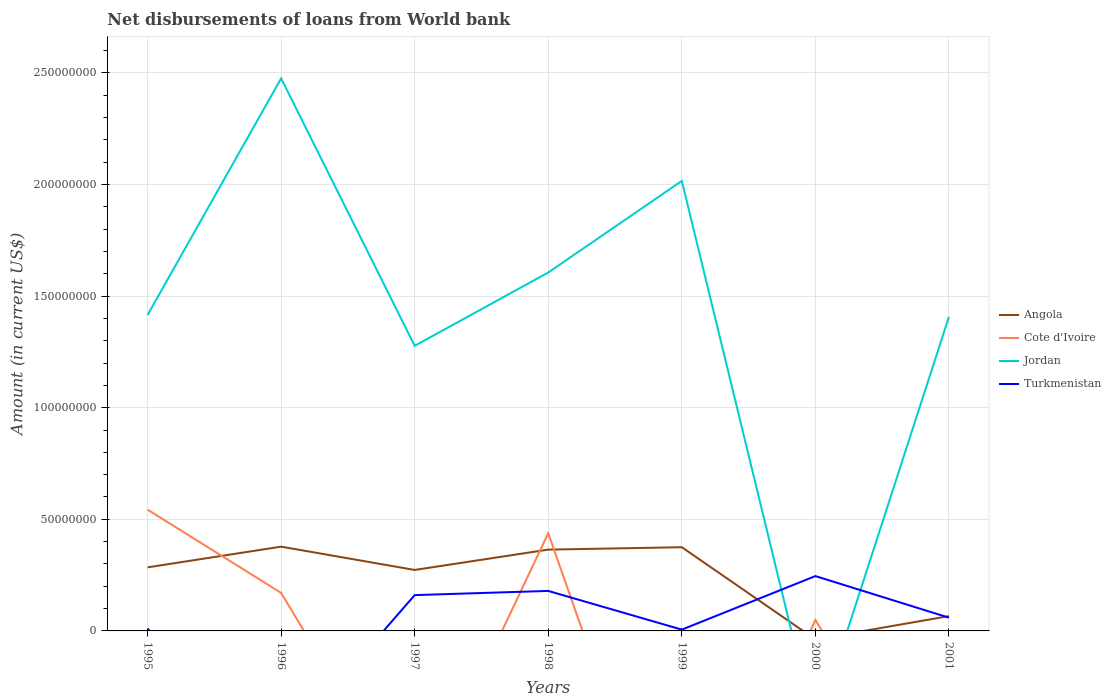Is the number of lines equal to the number of legend labels?
Your response must be concise. No. Across all years, what is the maximum amount of loan disbursed from World Bank in Jordan?
Offer a very short reply. 0. What is the total amount of loan disbursed from World Bank in Turkmenistan in the graph?
Provide a short and direct response. 1.86e+07. What is the difference between the highest and the second highest amount of loan disbursed from World Bank in Jordan?
Offer a very short reply. 2.48e+08. What is the difference between the highest and the lowest amount of loan disbursed from World Bank in Cote d'Ivoire?
Provide a short and direct response. 2. How many lines are there?
Provide a succinct answer. 4. How many years are there in the graph?
Your answer should be compact. 7. Are the values on the major ticks of Y-axis written in scientific E-notation?
Your answer should be very brief. No. Does the graph contain any zero values?
Offer a very short reply. Yes. Does the graph contain grids?
Make the answer very short. Yes. Where does the legend appear in the graph?
Your response must be concise. Center right. How many legend labels are there?
Offer a terse response. 4. How are the legend labels stacked?
Give a very brief answer. Vertical. What is the title of the graph?
Provide a succinct answer. Net disbursements of loans from World bank. What is the label or title of the Y-axis?
Offer a very short reply. Amount (in current US$). What is the Amount (in current US$) in Angola in 1995?
Make the answer very short. 2.85e+07. What is the Amount (in current US$) in Cote d'Ivoire in 1995?
Make the answer very short. 5.43e+07. What is the Amount (in current US$) of Jordan in 1995?
Make the answer very short. 1.42e+08. What is the Amount (in current US$) in Turkmenistan in 1995?
Ensure brevity in your answer.  9.57e+05. What is the Amount (in current US$) in Angola in 1996?
Ensure brevity in your answer.  3.78e+07. What is the Amount (in current US$) of Cote d'Ivoire in 1996?
Provide a succinct answer. 1.70e+07. What is the Amount (in current US$) in Jordan in 1996?
Offer a very short reply. 2.48e+08. What is the Amount (in current US$) of Turkmenistan in 1996?
Provide a succinct answer. 0. What is the Amount (in current US$) in Angola in 1997?
Your response must be concise. 2.73e+07. What is the Amount (in current US$) in Cote d'Ivoire in 1997?
Give a very brief answer. 0. What is the Amount (in current US$) of Jordan in 1997?
Keep it short and to the point. 1.28e+08. What is the Amount (in current US$) of Turkmenistan in 1997?
Give a very brief answer. 1.60e+07. What is the Amount (in current US$) of Angola in 1998?
Offer a terse response. 3.64e+07. What is the Amount (in current US$) in Cote d'Ivoire in 1998?
Give a very brief answer. 4.38e+07. What is the Amount (in current US$) in Jordan in 1998?
Offer a very short reply. 1.61e+08. What is the Amount (in current US$) in Turkmenistan in 1998?
Your answer should be compact. 1.79e+07. What is the Amount (in current US$) in Angola in 1999?
Your answer should be compact. 3.75e+07. What is the Amount (in current US$) of Jordan in 1999?
Offer a terse response. 2.02e+08. What is the Amount (in current US$) in Turkmenistan in 1999?
Offer a terse response. 5.75e+05. What is the Amount (in current US$) of Cote d'Ivoire in 2000?
Your answer should be compact. 4.92e+06. What is the Amount (in current US$) of Jordan in 2000?
Offer a very short reply. 0. What is the Amount (in current US$) of Turkmenistan in 2000?
Offer a very short reply. 2.46e+07. What is the Amount (in current US$) in Angola in 2001?
Keep it short and to the point. 6.63e+06. What is the Amount (in current US$) in Jordan in 2001?
Your answer should be compact. 1.41e+08. What is the Amount (in current US$) in Turkmenistan in 2001?
Give a very brief answer. 5.93e+06. Across all years, what is the maximum Amount (in current US$) in Angola?
Your answer should be very brief. 3.78e+07. Across all years, what is the maximum Amount (in current US$) in Cote d'Ivoire?
Your answer should be very brief. 5.43e+07. Across all years, what is the maximum Amount (in current US$) of Jordan?
Your answer should be very brief. 2.48e+08. Across all years, what is the maximum Amount (in current US$) of Turkmenistan?
Give a very brief answer. 2.46e+07. Across all years, what is the minimum Amount (in current US$) in Jordan?
Ensure brevity in your answer.  0. What is the total Amount (in current US$) of Angola in the graph?
Your response must be concise. 1.74e+08. What is the total Amount (in current US$) of Cote d'Ivoire in the graph?
Provide a short and direct response. 1.20e+08. What is the total Amount (in current US$) of Jordan in the graph?
Keep it short and to the point. 1.02e+09. What is the total Amount (in current US$) in Turkmenistan in the graph?
Give a very brief answer. 6.60e+07. What is the difference between the Amount (in current US$) in Angola in 1995 and that in 1996?
Your answer should be compact. -9.28e+06. What is the difference between the Amount (in current US$) of Cote d'Ivoire in 1995 and that in 1996?
Provide a short and direct response. 3.73e+07. What is the difference between the Amount (in current US$) of Jordan in 1995 and that in 1996?
Make the answer very short. -1.06e+08. What is the difference between the Amount (in current US$) of Angola in 1995 and that in 1997?
Your answer should be compact. 1.16e+06. What is the difference between the Amount (in current US$) of Jordan in 1995 and that in 1997?
Your response must be concise. 1.38e+07. What is the difference between the Amount (in current US$) in Turkmenistan in 1995 and that in 1997?
Make the answer very short. -1.51e+07. What is the difference between the Amount (in current US$) of Angola in 1995 and that in 1998?
Offer a very short reply. -7.95e+06. What is the difference between the Amount (in current US$) of Cote d'Ivoire in 1995 and that in 1998?
Offer a terse response. 1.06e+07. What is the difference between the Amount (in current US$) in Jordan in 1995 and that in 1998?
Your response must be concise. -1.90e+07. What is the difference between the Amount (in current US$) of Turkmenistan in 1995 and that in 1998?
Provide a short and direct response. -1.70e+07. What is the difference between the Amount (in current US$) of Angola in 1995 and that in 1999?
Keep it short and to the point. -9.03e+06. What is the difference between the Amount (in current US$) of Jordan in 1995 and that in 1999?
Your answer should be compact. -6.01e+07. What is the difference between the Amount (in current US$) of Turkmenistan in 1995 and that in 1999?
Your answer should be compact. 3.82e+05. What is the difference between the Amount (in current US$) in Cote d'Ivoire in 1995 and that in 2000?
Your response must be concise. 4.94e+07. What is the difference between the Amount (in current US$) in Turkmenistan in 1995 and that in 2000?
Give a very brief answer. -2.36e+07. What is the difference between the Amount (in current US$) in Angola in 1995 and that in 2001?
Give a very brief answer. 2.18e+07. What is the difference between the Amount (in current US$) in Jordan in 1995 and that in 2001?
Keep it short and to the point. 7.99e+05. What is the difference between the Amount (in current US$) in Turkmenistan in 1995 and that in 2001?
Offer a very short reply. -4.98e+06. What is the difference between the Amount (in current US$) of Angola in 1996 and that in 1997?
Keep it short and to the point. 1.04e+07. What is the difference between the Amount (in current US$) in Jordan in 1996 and that in 1997?
Provide a succinct answer. 1.20e+08. What is the difference between the Amount (in current US$) of Angola in 1996 and that in 1998?
Your answer should be very brief. 1.33e+06. What is the difference between the Amount (in current US$) of Cote d'Ivoire in 1996 and that in 1998?
Keep it short and to the point. -2.68e+07. What is the difference between the Amount (in current US$) of Jordan in 1996 and that in 1998?
Your response must be concise. 8.70e+07. What is the difference between the Amount (in current US$) in Angola in 1996 and that in 1999?
Provide a short and direct response. 2.51e+05. What is the difference between the Amount (in current US$) of Jordan in 1996 and that in 1999?
Offer a terse response. 4.59e+07. What is the difference between the Amount (in current US$) of Cote d'Ivoire in 1996 and that in 2000?
Your answer should be very brief. 1.21e+07. What is the difference between the Amount (in current US$) of Angola in 1996 and that in 2001?
Keep it short and to the point. 3.11e+07. What is the difference between the Amount (in current US$) of Jordan in 1996 and that in 2001?
Give a very brief answer. 1.07e+08. What is the difference between the Amount (in current US$) in Angola in 1997 and that in 1998?
Give a very brief answer. -9.11e+06. What is the difference between the Amount (in current US$) of Jordan in 1997 and that in 1998?
Your answer should be very brief. -3.28e+07. What is the difference between the Amount (in current US$) in Turkmenistan in 1997 and that in 1998?
Ensure brevity in your answer.  -1.87e+06. What is the difference between the Amount (in current US$) of Angola in 1997 and that in 1999?
Provide a succinct answer. -1.02e+07. What is the difference between the Amount (in current US$) of Jordan in 1997 and that in 1999?
Your response must be concise. -7.39e+07. What is the difference between the Amount (in current US$) in Turkmenistan in 1997 and that in 1999?
Your answer should be compact. 1.55e+07. What is the difference between the Amount (in current US$) of Turkmenistan in 1997 and that in 2000?
Provide a succinct answer. -8.52e+06. What is the difference between the Amount (in current US$) of Angola in 1997 and that in 2001?
Offer a terse response. 2.07e+07. What is the difference between the Amount (in current US$) of Jordan in 1997 and that in 2001?
Your answer should be very brief. -1.30e+07. What is the difference between the Amount (in current US$) in Turkmenistan in 1997 and that in 2001?
Ensure brevity in your answer.  1.01e+07. What is the difference between the Amount (in current US$) of Angola in 1998 and that in 1999?
Make the answer very short. -1.08e+06. What is the difference between the Amount (in current US$) of Jordan in 1998 and that in 1999?
Ensure brevity in your answer.  -4.10e+07. What is the difference between the Amount (in current US$) in Turkmenistan in 1998 and that in 1999?
Provide a short and direct response. 1.73e+07. What is the difference between the Amount (in current US$) in Cote d'Ivoire in 1998 and that in 2000?
Offer a terse response. 3.89e+07. What is the difference between the Amount (in current US$) in Turkmenistan in 1998 and that in 2000?
Make the answer very short. -6.65e+06. What is the difference between the Amount (in current US$) of Angola in 1998 and that in 2001?
Ensure brevity in your answer.  2.98e+07. What is the difference between the Amount (in current US$) in Jordan in 1998 and that in 2001?
Provide a succinct answer. 1.98e+07. What is the difference between the Amount (in current US$) of Turkmenistan in 1998 and that in 2001?
Your answer should be very brief. 1.20e+07. What is the difference between the Amount (in current US$) in Turkmenistan in 1999 and that in 2000?
Offer a terse response. -2.40e+07. What is the difference between the Amount (in current US$) in Angola in 1999 and that in 2001?
Provide a short and direct response. 3.09e+07. What is the difference between the Amount (in current US$) of Jordan in 1999 and that in 2001?
Your answer should be compact. 6.09e+07. What is the difference between the Amount (in current US$) of Turkmenistan in 1999 and that in 2001?
Offer a very short reply. -5.36e+06. What is the difference between the Amount (in current US$) in Turkmenistan in 2000 and that in 2001?
Offer a very short reply. 1.86e+07. What is the difference between the Amount (in current US$) in Angola in 1995 and the Amount (in current US$) in Cote d'Ivoire in 1996?
Make the answer very short. 1.14e+07. What is the difference between the Amount (in current US$) of Angola in 1995 and the Amount (in current US$) of Jordan in 1996?
Offer a very short reply. -2.19e+08. What is the difference between the Amount (in current US$) in Cote d'Ivoire in 1995 and the Amount (in current US$) in Jordan in 1996?
Ensure brevity in your answer.  -1.93e+08. What is the difference between the Amount (in current US$) of Angola in 1995 and the Amount (in current US$) of Jordan in 1997?
Offer a terse response. -9.93e+07. What is the difference between the Amount (in current US$) of Angola in 1995 and the Amount (in current US$) of Turkmenistan in 1997?
Offer a very short reply. 1.24e+07. What is the difference between the Amount (in current US$) of Cote d'Ivoire in 1995 and the Amount (in current US$) of Jordan in 1997?
Make the answer very short. -7.34e+07. What is the difference between the Amount (in current US$) of Cote d'Ivoire in 1995 and the Amount (in current US$) of Turkmenistan in 1997?
Make the answer very short. 3.83e+07. What is the difference between the Amount (in current US$) in Jordan in 1995 and the Amount (in current US$) in Turkmenistan in 1997?
Your response must be concise. 1.25e+08. What is the difference between the Amount (in current US$) in Angola in 1995 and the Amount (in current US$) in Cote d'Ivoire in 1998?
Your response must be concise. -1.53e+07. What is the difference between the Amount (in current US$) in Angola in 1995 and the Amount (in current US$) in Jordan in 1998?
Provide a short and direct response. -1.32e+08. What is the difference between the Amount (in current US$) of Angola in 1995 and the Amount (in current US$) of Turkmenistan in 1998?
Make the answer very short. 1.06e+07. What is the difference between the Amount (in current US$) in Cote d'Ivoire in 1995 and the Amount (in current US$) in Jordan in 1998?
Make the answer very short. -1.06e+08. What is the difference between the Amount (in current US$) of Cote d'Ivoire in 1995 and the Amount (in current US$) of Turkmenistan in 1998?
Your answer should be compact. 3.64e+07. What is the difference between the Amount (in current US$) in Jordan in 1995 and the Amount (in current US$) in Turkmenistan in 1998?
Offer a very short reply. 1.24e+08. What is the difference between the Amount (in current US$) in Angola in 1995 and the Amount (in current US$) in Jordan in 1999?
Make the answer very short. -1.73e+08. What is the difference between the Amount (in current US$) of Angola in 1995 and the Amount (in current US$) of Turkmenistan in 1999?
Keep it short and to the point. 2.79e+07. What is the difference between the Amount (in current US$) in Cote d'Ivoire in 1995 and the Amount (in current US$) in Jordan in 1999?
Your response must be concise. -1.47e+08. What is the difference between the Amount (in current US$) of Cote d'Ivoire in 1995 and the Amount (in current US$) of Turkmenistan in 1999?
Offer a terse response. 5.38e+07. What is the difference between the Amount (in current US$) in Jordan in 1995 and the Amount (in current US$) in Turkmenistan in 1999?
Offer a terse response. 1.41e+08. What is the difference between the Amount (in current US$) in Angola in 1995 and the Amount (in current US$) in Cote d'Ivoire in 2000?
Provide a succinct answer. 2.36e+07. What is the difference between the Amount (in current US$) of Angola in 1995 and the Amount (in current US$) of Turkmenistan in 2000?
Make the answer very short. 3.90e+06. What is the difference between the Amount (in current US$) in Cote d'Ivoire in 1995 and the Amount (in current US$) in Turkmenistan in 2000?
Provide a short and direct response. 2.98e+07. What is the difference between the Amount (in current US$) in Jordan in 1995 and the Amount (in current US$) in Turkmenistan in 2000?
Your answer should be very brief. 1.17e+08. What is the difference between the Amount (in current US$) in Angola in 1995 and the Amount (in current US$) in Jordan in 2001?
Your answer should be compact. -1.12e+08. What is the difference between the Amount (in current US$) in Angola in 1995 and the Amount (in current US$) in Turkmenistan in 2001?
Give a very brief answer. 2.25e+07. What is the difference between the Amount (in current US$) of Cote d'Ivoire in 1995 and the Amount (in current US$) of Jordan in 2001?
Your response must be concise. -8.64e+07. What is the difference between the Amount (in current US$) of Cote d'Ivoire in 1995 and the Amount (in current US$) of Turkmenistan in 2001?
Keep it short and to the point. 4.84e+07. What is the difference between the Amount (in current US$) of Jordan in 1995 and the Amount (in current US$) of Turkmenistan in 2001?
Provide a short and direct response. 1.36e+08. What is the difference between the Amount (in current US$) of Angola in 1996 and the Amount (in current US$) of Jordan in 1997?
Provide a succinct answer. -9.00e+07. What is the difference between the Amount (in current US$) in Angola in 1996 and the Amount (in current US$) in Turkmenistan in 1997?
Provide a succinct answer. 2.17e+07. What is the difference between the Amount (in current US$) in Cote d'Ivoire in 1996 and the Amount (in current US$) in Jordan in 1997?
Your answer should be compact. -1.11e+08. What is the difference between the Amount (in current US$) in Cote d'Ivoire in 1996 and the Amount (in current US$) in Turkmenistan in 1997?
Provide a short and direct response. 9.91e+05. What is the difference between the Amount (in current US$) of Jordan in 1996 and the Amount (in current US$) of Turkmenistan in 1997?
Offer a very short reply. 2.32e+08. What is the difference between the Amount (in current US$) of Angola in 1996 and the Amount (in current US$) of Cote d'Ivoire in 1998?
Keep it short and to the point. -6.04e+06. What is the difference between the Amount (in current US$) of Angola in 1996 and the Amount (in current US$) of Jordan in 1998?
Your answer should be very brief. -1.23e+08. What is the difference between the Amount (in current US$) in Angola in 1996 and the Amount (in current US$) in Turkmenistan in 1998?
Give a very brief answer. 1.98e+07. What is the difference between the Amount (in current US$) in Cote d'Ivoire in 1996 and the Amount (in current US$) in Jordan in 1998?
Keep it short and to the point. -1.44e+08. What is the difference between the Amount (in current US$) of Cote d'Ivoire in 1996 and the Amount (in current US$) of Turkmenistan in 1998?
Provide a succinct answer. -8.82e+05. What is the difference between the Amount (in current US$) of Jordan in 1996 and the Amount (in current US$) of Turkmenistan in 1998?
Offer a very short reply. 2.30e+08. What is the difference between the Amount (in current US$) of Angola in 1996 and the Amount (in current US$) of Jordan in 1999?
Keep it short and to the point. -1.64e+08. What is the difference between the Amount (in current US$) in Angola in 1996 and the Amount (in current US$) in Turkmenistan in 1999?
Give a very brief answer. 3.72e+07. What is the difference between the Amount (in current US$) in Cote d'Ivoire in 1996 and the Amount (in current US$) in Jordan in 1999?
Offer a very short reply. -1.85e+08. What is the difference between the Amount (in current US$) in Cote d'Ivoire in 1996 and the Amount (in current US$) in Turkmenistan in 1999?
Give a very brief answer. 1.65e+07. What is the difference between the Amount (in current US$) in Jordan in 1996 and the Amount (in current US$) in Turkmenistan in 1999?
Provide a succinct answer. 2.47e+08. What is the difference between the Amount (in current US$) in Angola in 1996 and the Amount (in current US$) in Cote d'Ivoire in 2000?
Provide a succinct answer. 3.28e+07. What is the difference between the Amount (in current US$) in Angola in 1996 and the Amount (in current US$) in Turkmenistan in 2000?
Offer a very short reply. 1.32e+07. What is the difference between the Amount (in current US$) in Cote d'Ivoire in 1996 and the Amount (in current US$) in Turkmenistan in 2000?
Keep it short and to the point. -7.53e+06. What is the difference between the Amount (in current US$) of Jordan in 1996 and the Amount (in current US$) of Turkmenistan in 2000?
Your answer should be compact. 2.23e+08. What is the difference between the Amount (in current US$) in Angola in 1996 and the Amount (in current US$) in Jordan in 2001?
Give a very brief answer. -1.03e+08. What is the difference between the Amount (in current US$) in Angola in 1996 and the Amount (in current US$) in Turkmenistan in 2001?
Your answer should be very brief. 3.18e+07. What is the difference between the Amount (in current US$) of Cote d'Ivoire in 1996 and the Amount (in current US$) of Jordan in 2001?
Your response must be concise. -1.24e+08. What is the difference between the Amount (in current US$) in Cote d'Ivoire in 1996 and the Amount (in current US$) in Turkmenistan in 2001?
Your answer should be very brief. 1.11e+07. What is the difference between the Amount (in current US$) of Jordan in 1996 and the Amount (in current US$) of Turkmenistan in 2001?
Your answer should be compact. 2.42e+08. What is the difference between the Amount (in current US$) in Angola in 1997 and the Amount (in current US$) in Cote d'Ivoire in 1998?
Provide a succinct answer. -1.65e+07. What is the difference between the Amount (in current US$) of Angola in 1997 and the Amount (in current US$) of Jordan in 1998?
Provide a succinct answer. -1.33e+08. What is the difference between the Amount (in current US$) in Angola in 1997 and the Amount (in current US$) in Turkmenistan in 1998?
Provide a short and direct response. 9.40e+06. What is the difference between the Amount (in current US$) in Jordan in 1997 and the Amount (in current US$) in Turkmenistan in 1998?
Ensure brevity in your answer.  1.10e+08. What is the difference between the Amount (in current US$) of Angola in 1997 and the Amount (in current US$) of Jordan in 1999?
Make the answer very short. -1.74e+08. What is the difference between the Amount (in current US$) in Angola in 1997 and the Amount (in current US$) in Turkmenistan in 1999?
Your response must be concise. 2.67e+07. What is the difference between the Amount (in current US$) of Jordan in 1997 and the Amount (in current US$) of Turkmenistan in 1999?
Provide a succinct answer. 1.27e+08. What is the difference between the Amount (in current US$) in Angola in 1997 and the Amount (in current US$) in Cote d'Ivoire in 2000?
Your answer should be compact. 2.24e+07. What is the difference between the Amount (in current US$) in Angola in 1997 and the Amount (in current US$) in Turkmenistan in 2000?
Give a very brief answer. 2.75e+06. What is the difference between the Amount (in current US$) of Jordan in 1997 and the Amount (in current US$) of Turkmenistan in 2000?
Give a very brief answer. 1.03e+08. What is the difference between the Amount (in current US$) of Angola in 1997 and the Amount (in current US$) of Jordan in 2001?
Keep it short and to the point. -1.13e+08. What is the difference between the Amount (in current US$) in Angola in 1997 and the Amount (in current US$) in Turkmenistan in 2001?
Your answer should be compact. 2.14e+07. What is the difference between the Amount (in current US$) of Jordan in 1997 and the Amount (in current US$) of Turkmenistan in 2001?
Your answer should be very brief. 1.22e+08. What is the difference between the Amount (in current US$) in Angola in 1998 and the Amount (in current US$) in Jordan in 1999?
Your answer should be very brief. -1.65e+08. What is the difference between the Amount (in current US$) of Angola in 1998 and the Amount (in current US$) of Turkmenistan in 1999?
Make the answer very short. 3.58e+07. What is the difference between the Amount (in current US$) of Cote d'Ivoire in 1998 and the Amount (in current US$) of Jordan in 1999?
Offer a terse response. -1.58e+08. What is the difference between the Amount (in current US$) of Cote d'Ivoire in 1998 and the Amount (in current US$) of Turkmenistan in 1999?
Your answer should be compact. 4.32e+07. What is the difference between the Amount (in current US$) of Jordan in 1998 and the Amount (in current US$) of Turkmenistan in 1999?
Offer a very short reply. 1.60e+08. What is the difference between the Amount (in current US$) in Angola in 1998 and the Amount (in current US$) in Cote d'Ivoire in 2000?
Make the answer very short. 3.15e+07. What is the difference between the Amount (in current US$) of Angola in 1998 and the Amount (in current US$) of Turkmenistan in 2000?
Your answer should be very brief. 1.19e+07. What is the difference between the Amount (in current US$) of Cote d'Ivoire in 1998 and the Amount (in current US$) of Turkmenistan in 2000?
Ensure brevity in your answer.  1.92e+07. What is the difference between the Amount (in current US$) in Jordan in 1998 and the Amount (in current US$) in Turkmenistan in 2000?
Make the answer very short. 1.36e+08. What is the difference between the Amount (in current US$) of Angola in 1998 and the Amount (in current US$) of Jordan in 2001?
Offer a very short reply. -1.04e+08. What is the difference between the Amount (in current US$) of Angola in 1998 and the Amount (in current US$) of Turkmenistan in 2001?
Your answer should be very brief. 3.05e+07. What is the difference between the Amount (in current US$) of Cote d'Ivoire in 1998 and the Amount (in current US$) of Jordan in 2001?
Your response must be concise. -9.69e+07. What is the difference between the Amount (in current US$) in Cote d'Ivoire in 1998 and the Amount (in current US$) in Turkmenistan in 2001?
Your response must be concise. 3.79e+07. What is the difference between the Amount (in current US$) in Jordan in 1998 and the Amount (in current US$) in Turkmenistan in 2001?
Provide a short and direct response. 1.55e+08. What is the difference between the Amount (in current US$) in Angola in 1999 and the Amount (in current US$) in Cote d'Ivoire in 2000?
Keep it short and to the point. 3.26e+07. What is the difference between the Amount (in current US$) of Angola in 1999 and the Amount (in current US$) of Turkmenistan in 2000?
Offer a terse response. 1.29e+07. What is the difference between the Amount (in current US$) of Jordan in 1999 and the Amount (in current US$) of Turkmenistan in 2000?
Offer a terse response. 1.77e+08. What is the difference between the Amount (in current US$) in Angola in 1999 and the Amount (in current US$) in Jordan in 2001?
Ensure brevity in your answer.  -1.03e+08. What is the difference between the Amount (in current US$) of Angola in 1999 and the Amount (in current US$) of Turkmenistan in 2001?
Your response must be concise. 3.16e+07. What is the difference between the Amount (in current US$) in Jordan in 1999 and the Amount (in current US$) in Turkmenistan in 2001?
Offer a very short reply. 1.96e+08. What is the difference between the Amount (in current US$) of Cote d'Ivoire in 2000 and the Amount (in current US$) of Jordan in 2001?
Provide a short and direct response. -1.36e+08. What is the difference between the Amount (in current US$) in Cote d'Ivoire in 2000 and the Amount (in current US$) in Turkmenistan in 2001?
Provide a short and direct response. -1.01e+06. What is the average Amount (in current US$) of Angola per year?
Keep it short and to the point. 2.49e+07. What is the average Amount (in current US$) in Cote d'Ivoire per year?
Keep it short and to the point. 1.72e+07. What is the average Amount (in current US$) in Jordan per year?
Your response must be concise. 1.46e+08. What is the average Amount (in current US$) in Turkmenistan per year?
Provide a succinct answer. 9.43e+06. In the year 1995, what is the difference between the Amount (in current US$) of Angola and Amount (in current US$) of Cote d'Ivoire?
Make the answer very short. -2.59e+07. In the year 1995, what is the difference between the Amount (in current US$) of Angola and Amount (in current US$) of Jordan?
Your response must be concise. -1.13e+08. In the year 1995, what is the difference between the Amount (in current US$) of Angola and Amount (in current US$) of Turkmenistan?
Offer a very short reply. 2.75e+07. In the year 1995, what is the difference between the Amount (in current US$) of Cote d'Ivoire and Amount (in current US$) of Jordan?
Ensure brevity in your answer.  -8.72e+07. In the year 1995, what is the difference between the Amount (in current US$) in Cote d'Ivoire and Amount (in current US$) in Turkmenistan?
Your answer should be compact. 5.34e+07. In the year 1995, what is the difference between the Amount (in current US$) of Jordan and Amount (in current US$) of Turkmenistan?
Make the answer very short. 1.41e+08. In the year 1996, what is the difference between the Amount (in current US$) of Angola and Amount (in current US$) of Cote d'Ivoire?
Offer a very short reply. 2.07e+07. In the year 1996, what is the difference between the Amount (in current US$) in Angola and Amount (in current US$) in Jordan?
Your response must be concise. -2.10e+08. In the year 1996, what is the difference between the Amount (in current US$) in Cote d'Ivoire and Amount (in current US$) in Jordan?
Ensure brevity in your answer.  -2.31e+08. In the year 1997, what is the difference between the Amount (in current US$) of Angola and Amount (in current US$) of Jordan?
Your response must be concise. -1.00e+08. In the year 1997, what is the difference between the Amount (in current US$) in Angola and Amount (in current US$) in Turkmenistan?
Offer a terse response. 1.13e+07. In the year 1997, what is the difference between the Amount (in current US$) in Jordan and Amount (in current US$) in Turkmenistan?
Keep it short and to the point. 1.12e+08. In the year 1998, what is the difference between the Amount (in current US$) in Angola and Amount (in current US$) in Cote d'Ivoire?
Your response must be concise. -7.36e+06. In the year 1998, what is the difference between the Amount (in current US$) in Angola and Amount (in current US$) in Jordan?
Ensure brevity in your answer.  -1.24e+08. In the year 1998, what is the difference between the Amount (in current US$) of Angola and Amount (in current US$) of Turkmenistan?
Provide a short and direct response. 1.85e+07. In the year 1998, what is the difference between the Amount (in current US$) of Cote d'Ivoire and Amount (in current US$) of Jordan?
Your response must be concise. -1.17e+08. In the year 1998, what is the difference between the Amount (in current US$) in Cote d'Ivoire and Amount (in current US$) in Turkmenistan?
Provide a short and direct response. 2.59e+07. In the year 1998, what is the difference between the Amount (in current US$) in Jordan and Amount (in current US$) in Turkmenistan?
Offer a terse response. 1.43e+08. In the year 1999, what is the difference between the Amount (in current US$) in Angola and Amount (in current US$) in Jordan?
Your response must be concise. -1.64e+08. In the year 1999, what is the difference between the Amount (in current US$) in Angola and Amount (in current US$) in Turkmenistan?
Your answer should be very brief. 3.69e+07. In the year 1999, what is the difference between the Amount (in current US$) of Jordan and Amount (in current US$) of Turkmenistan?
Offer a very short reply. 2.01e+08. In the year 2000, what is the difference between the Amount (in current US$) in Cote d'Ivoire and Amount (in current US$) in Turkmenistan?
Your response must be concise. -1.96e+07. In the year 2001, what is the difference between the Amount (in current US$) in Angola and Amount (in current US$) in Jordan?
Provide a short and direct response. -1.34e+08. In the year 2001, what is the difference between the Amount (in current US$) in Angola and Amount (in current US$) in Turkmenistan?
Provide a short and direct response. 7.01e+05. In the year 2001, what is the difference between the Amount (in current US$) of Jordan and Amount (in current US$) of Turkmenistan?
Offer a very short reply. 1.35e+08. What is the ratio of the Amount (in current US$) in Angola in 1995 to that in 1996?
Your answer should be compact. 0.75. What is the ratio of the Amount (in current US$) in Cote d'Ivoire in 1995 to that in 1996?
Your answer should be very brief. 3.19. What is the ratio of the Amount (in current US$) of Jordan in 1995 to that in 1996?
Your answer should be very brief. 0.57. What is the ratio of the Amount (in current US$) in Angola in 1995 to that in 1997?
Make the answer very short. 1.04. What is the ratio of the Amount (in current US$) of Jordan in 1995 to that in 1997?
Ensure brevity in your answer.  1.11. What is the ratio of the Amount (in current US$) of Turkmenistan in 1995 to that in 1997?
Provide a short and direct response. 0.06. What is the ratio of the Amount (in current US$) of Angola in 1995 to that in 1998?
Ensure brevity in your answer.  0.78. What is the ratio of the Amount (in current US$) in Cote d'Ivoire in 1995 to that in 1998?
Ensure brevity in your answer.  1.24. What is the ratio of the Amount (in current US$) of Jordan in 1995 to that in 1998?
Your response must be concise. 0.88. What is the ratio of the Amount (in current US$) in Turkmenistan in 1995 to that in 1998?
Keep it short and to the point. 0.05. What is the ratio of the Amount (in current US$) in Angola in 1995 to that in 1999?
Your answer should be very brief. 0.76. What is the ratio of the Amount (in current US$) in Jordan in 1995 to that in 1999?
Offer a very short reply. 0.7. What is the ratio of the Amount (in current US$) in Turkmenistan in 1995 to that in 1999?
Your answer should be very brief. 1.66. What is the ratio of the Amount (in current US$) of Cote d'Ivoire in 1995 to that in 2000?
Your answer should be very brief. 11.05. What is the ratio of the Amount (in current US$) of Turkmenistan in 1995 to that in 2000?
Ensure brevity in your answer.  0.04. What is the ratio of the Amount (in current US$) of Angola in 1995 to that in 2001?
Make the answer very short. 4.29. What is the ratio of the Amount (in current US$) of Jordan in 1995 to that in 2001?
Make the answer very short. 1.01. What is the ratio of the Amount (in current US$) of Turkmenistan in 1995 to that in 2001?
Your answer should be very brief. 0.16. What is the ratio of the Amount (in current US$) of Angola in 1996 to that in 1997?
Your response must be concise. 1.38. What is the ratio of the Amount (in current US$) in Jordan in 1996 to that in 1997?
Keep it short and to the point. 1.94. What is the ratio of the Amount (in current US$) of Angola in 1996 to that in 1998?
Your answer should be very brief. 1.04. What is the ratio of the Amount (in current US$) in Cote d'Ivoire in 1996 to that in 1998?
Offer a very short reply. 0.39. What is the ratio of the Amount (in current US$) of Jordan in 1996 to that in 1998?
Provide a short and direct response. 1.54. What is the ratio of the Amount (in current US$) in Jordan in 1996 to that in 1999?
Your answer should be very brief. 1.23. What is the ratio of the Amount (in current US$) of Cote d'Ivoire in 1996 to that in 2000?
Make the answer very short. 3.46. What is the ratio of the Amount (in current US$) in Angola in 1996 to that in 2001?
Your answer should be very brief. 5.69. What is the ratio of the Amount (in current US$) in Jordan in 1996 to that in 2001?
Keep it short and to the point. 1.76. What is the ratio of the Amount (in current US$) in Angola in 1997 to that in 1998?
Your response must be concise. 0.75. What is the ratio of the Amount (in current US$) of Jordan in 1997 to that in 1998?
Offer a terse response. 0.8. What is the ratio of the Amount (in current US$) in Turkmenistan in 1997 to that in 1998?
Offer a very short reply. 0.9. What is the ratio of the Amount (in current US$) of Angola in 1997 to that in 1999?
Provide a short and direct response. 0.73. What is the ratio of the Amount (in current US$) of Jordan in 1997 to that in 1999?
Provide a short and direct response. 0.63. What is the ratio of the Amount (in current US$) in Turkmenistan in 1997 to that in 1999?
Make the answer very short. 27.9. What is the ratio of the Amount (in current US$) in Turkmenistan in 1997 to that in 2000?
Give a very brief answer. 0.65. What is the ratio of the Amount (in current US$) of Angola in 1997 to that in 2001?
Your answer should be very brief. 4.12. What is the ratio of the Amount (in current US$) in Jordan in 1997 to that in 2001?
Provide a short and direct response. 0.91. What is the ratio of the Amount (in current US$) of Turkmenistan in 1997 to that in 2001?
Offer a very short reply. 2.7. What is the ratio of the Amount (in current US$) in Angola in 1998 to that in 1999?
Offer a terse response. 0.97. What is the ratio of the Amount (in current US$) of Jordan in 1998 to that in 1999?
Keep it short and to the point. 0.8. What is the ratio of the Amount (in current US$) of Turkmenistan in 1998 to that in 1999?
Keep it short and to the point. 31.16. What is the ratio of the Amount (in current US$) in Cote d'Ivoire in 1998 to that in 2000?
Provide a succinct answer. 8.9. What is the ratio of the Amount (in current US$) in Turkmenistan in 1998 to that in 2000?
Your answer should be compact. 0.73. What is the ratio of the Amount (in current US$) of Angola in 1998 to that in 2001?
Provide a succinct answer. 5.49. What is the ratio of the Amount (in current US$) of Jordan in 1998 to that in 2001?
Keep it short and to the point. 1.14. What is the ratio of the Amount (in current US$) of Turkmenistan in 1998 to that in 2001?
Ensure brevity in your answer.  3.02. What is the ratio of the Amount (in current US$) in Turkmenistan in 1999 to that in 2000?
Your answer should be compact. 0.02. What is the ratio of the Amount (in current US$) in Angola in 1999 to that in 2001?
Make the answer very short. 5.65. What is the ratio of the Amount (in current US$) of Jordan in 1999 to that in 2001?
Ensure brevity in your answer.  1.43. What is the ratio of the Amount (in current US$) of Turkmenistan in 1999 to that in 2001?
Provide a short and direct response. 0.1. What is the ratio of the Amount (in current US$) in Turkmenistan in 2000 to that in 2001?
Make the answer very short. 4.14. What is the difference between the highest and the second highest Amount (in current US$) of Angola?
Provide a short and direct response. 2.51e+05. What is the difference between the highest and the second highest Amount (in current US$) of Cote d'Ivoire?
Your answer should be very brief. 1.06e+07. What is the difference between the highest and the second highest Amount (in current US$) of Jordan?
Give a very brief answer. 4.59e+07. What is the difference between the highest and the second highest Amount (in current US$) in Turkmenistan?
Ensure brevity in your answer.  6.65e+06. What is the difference between the highest and the lowest Amount (in current US$) in Angola?
Provide a short and direct response. 3.78e+07. What is the difference between the highest and the lowest Amount (in current US$) in Cote d'Ivoire?
Ensure brevity in your answer.  5.43e+07. What is the difference between the highest and the lowest Amount (in current US$) of Jordan?
Your answer should be compact. 2.48e+08. What is the difference between the highest and the lowest Amount (in current US$) of Turkmenistan?
Your answer should be compact. 2.46e+07. 